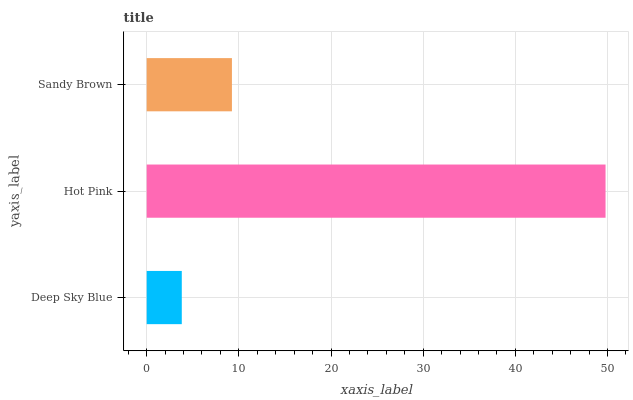Is Deep Sky Blue the minimum?
Answer yes or no. Yes. Is Hot Pink the maximum?
Answer yes or no. Yes. Is Sandy Brown the minimum?
Answer yes or no. No. Is Sandy Brown the maximum?
Answer yes or no. No. Is Hot Pink greater than Sandy Brown?
Answer yes or no. Yes. Is Sandy Brown less than Hot Pink?
Answer yes or no. Yes. Is Sandy Brown greater than Hot Pink?
Answer yes or no. No. Is Hot Pink less than Sandy Brown?
Answer yes or no. No. Is Sandy Brown the high median?
Answer yes or no. Yes. Is Sandy Brown the low median?
Answer yes or no. Yes. Is Hot Pink the high median?
Answer yes or no. No. Is Deep Sky Blue the low median?
Answer yes or no. No. 